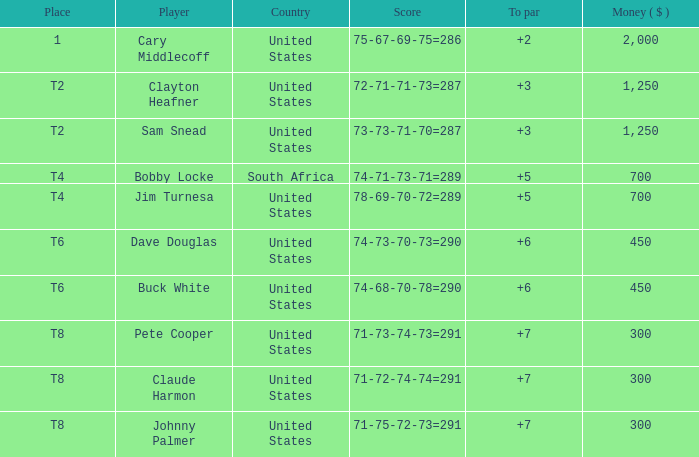What is Claude Harmon's Place? T8. 